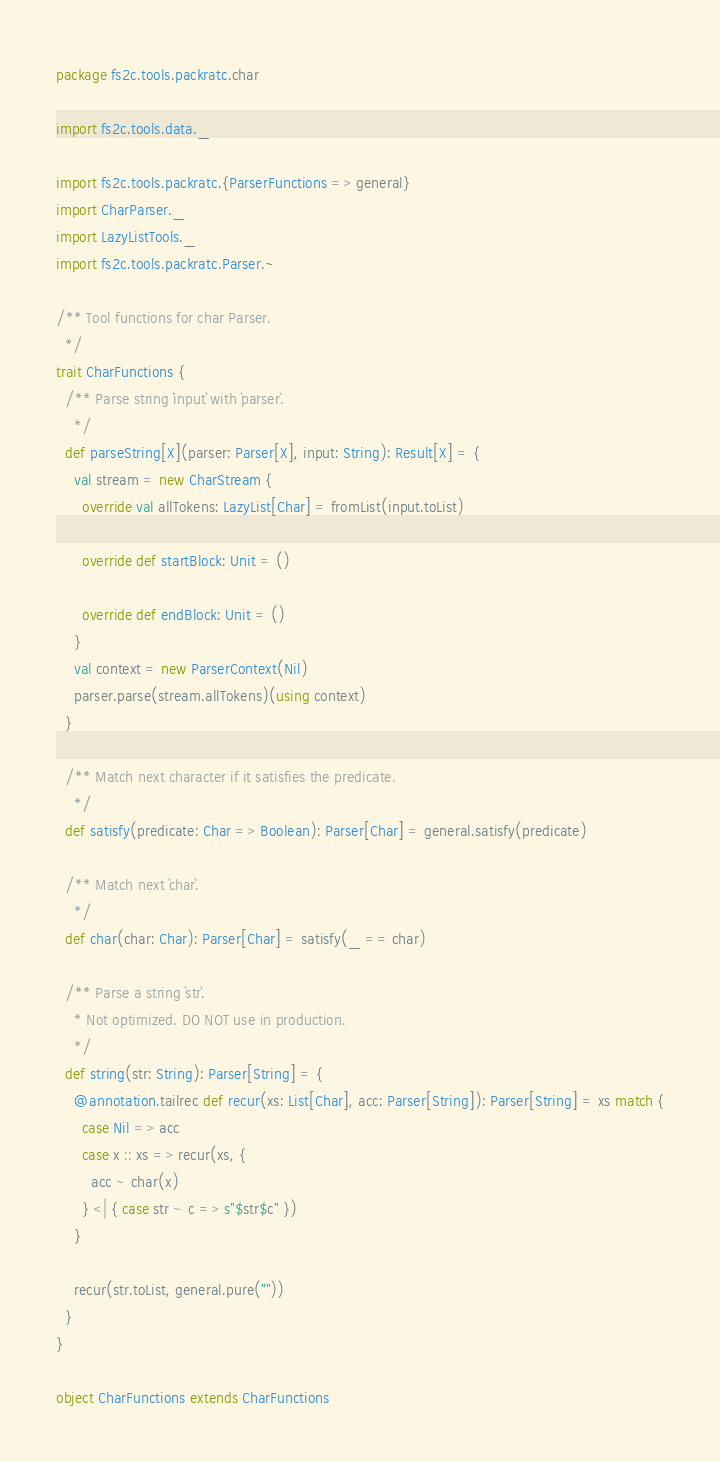<code> <loc_0><loc_0><loc_500><loc_500><_Scala_>package fs2c.tools.packratc.char

import fs2c.tools.data._

import fs2c.tools.packratc.{ParserFunctions => general}
import CharParser._
import LazyListTools._
import fs2c.tools.packratc.Parser.~

/** Tool functions for char Parser.
  */
trait CharFunctions {
  /** Parse string `input` with `parser`.
    */
  def parseString[X](parser: Parser[X], input: String): Result[X] = {
    val stream = new CharStream {
      override val allTokens: LazyList[Char] = fromList(input.toList)

      override def startBlock: Unit = ()

      override def endBlock: Unit = ()
    }
    val context = new ParserContext(Nil)
    parser.parse(stream.allTokens)(using context)
  }

  /** Match next character if it satisfies the predicate.
    */
  def satisfy(predicate: Char => Boolean): Parser[Char] = general.satisfy(predicate)

  /** Match next `char`.
    */
  def char(char: Char): Parser[Char] = satisfy(_ == char)

  /** Parse a string `str`. 
    * Not optimized. DO NOT use in production.
    */
  def string(str: String): Parser[String] = {
    @annotation.tailrec def recur(xs: List[Char], acc: Parser[String]): Parser[String] = xs match {
      case Nil => acc
      case x :: xs => recur(xs, {
        acc ~ char(x)
      } <| { case str ~ c => s"$str$c" })
    }

    recur(str.toList, general.pure(""))
  }
}

object CharFunctions extends CharFunctions
</code> 